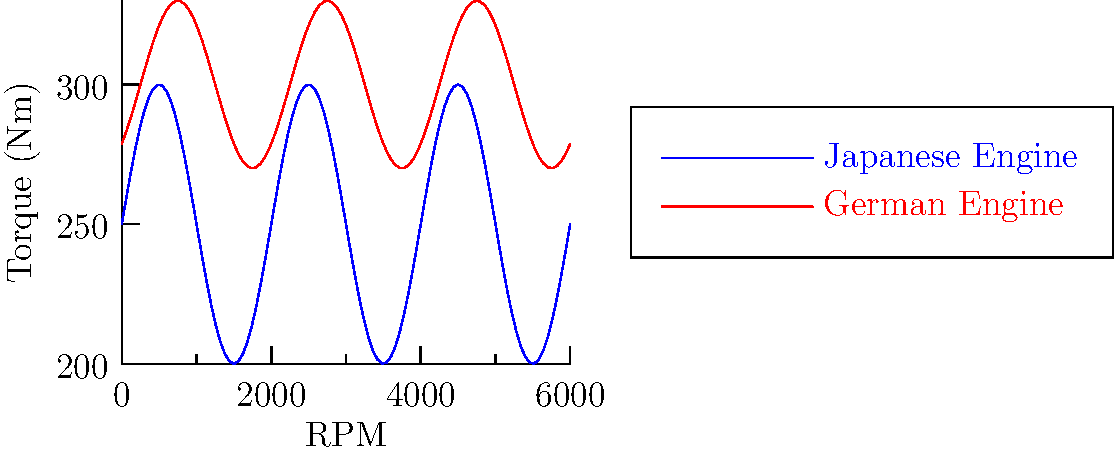Analyze the torque curves for a Japanese and German engine shown in the graph. Which engine provides a more consistent torque output across the RPM range, and how does this characteristic typically affect the driving experience? Explain the implications for tuning each engine type. To answer this question, we need to analyze the torque curves step by step:

1. Observe the overall shape of both curves:
   - The Japanese engine (blue) has a more pronounced wave pattern.
   - The German engine (red) has a flatter, more consistent curve.

2. Calculate the torque variation:
   - Japanese engine: Varies approximately between 200 Nm and 300 Nm.
   - German engine: Varies approximately between 270 Nm and 330 Nm.

3. Assess consistency:
   - The German engine has a smaller torque variation (about 60 Nm) compared to the Japanese engine (about 100 Nm).
   - This indicates that the German engine provides more consistent torque across the RPM range.

4. Driving experience implications:
   - More consistent torque (German engine) typically results in smoother power delivery and more predictable acceleration.
   - The Japanese engine's larger torque variations might provide a more "exciting" feel with noticeable power surges.

5. Tuning implications:
   - Japanese engine: Tuning might focus on smoothing out the torque curve or enhancing the power peaks for specific driving styles.
   - German engine: Tuning could aim to maintain the flat torque curve while increasing overall output, or slightly increasing torque at specific RPM ranges for particular applications.

6. Engine characteristics:
   - Japanese engines often prioritize high-revving performance and sharp power delivery.
   - German engines typically focus on broad power bands and refined, consistent performance.

These differences reflect the design philosophies and priorities of Japanese and German automotive engineering, which influence the approach to tuning and modification for each type of engine.
Answer: The German engine provides more consistent torque output, resulting in smoother power delivery. Tuning approaches differ: Japanese engines often focus on enhancing power peaks, while German engines typically aim to maintain broad, consistent power bands. 